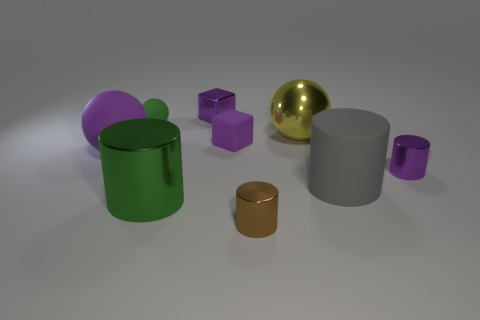Subtract all small purple shiny cylinders. How many cylinders are left? 3 Subtract all purple cylinders. How many cylinders are left? 3 Subtract 1 cylinders. How many cylinders are left? 3 Subtract all balls. How many objects are left? 6 Subtract all purple cylinders. Subtract all red blocks. How many cylinders are left? 3 Add 4 purple objects. How many purple objects are left? 8 Add 9 tiny green rubber balls. How many tiny green rubber balls exist? 10 Subtract 0 cyan cubes. How many objects are left? 9 Subtract all tiny cylinders. Subtract all brown things. How many objects are left? 6 